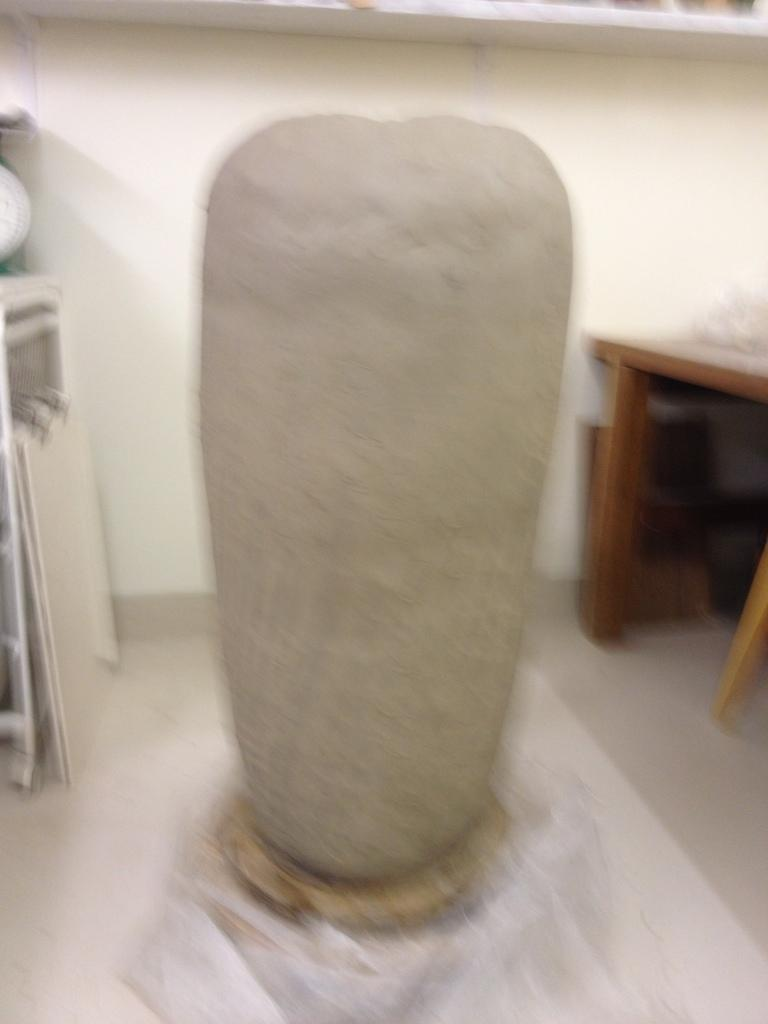What is the main object in the center of the image? There is a stone in the center of the image. What structure is located on the right side of the image? There is a table on the right side of the image. What can be seen in the background of the image? There is a wall in the background of the image. What type of silk fabric is draped over the stone in the image? There is no silk fabric present in the image; it features a stone, a table, and a wall in the background. 